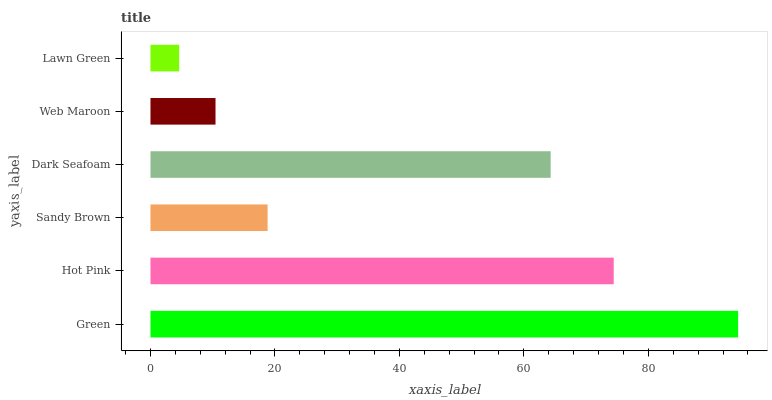Is Lawn Green the minimum?
Answer yes or no. Yes. Is Green the maximum?
Answer yes or no. Yes. Is Hot Pink the minimum?
Answer yes or no. No. Is Hot Pink the maximum?
Answer yes or no. No. Is Green greater than Hot Pink?
Answer yes or no. Yes. Is Hot Pink less than Green?
Answer yes or no. Yes. Is Hot Pink greater than Green?
Answer yes or no. No. Is Green less than Hot Pink?
Answer yes or no. No. Is Dark Seafoam the high median?
Answer yes or no. Yes. Is Sandy Brown the low median?
Answer yes or no. Yes. Is Sandy Brown the high median?
Answer yes or no. No. Is Green the low median?
Answer yes or no. No. 